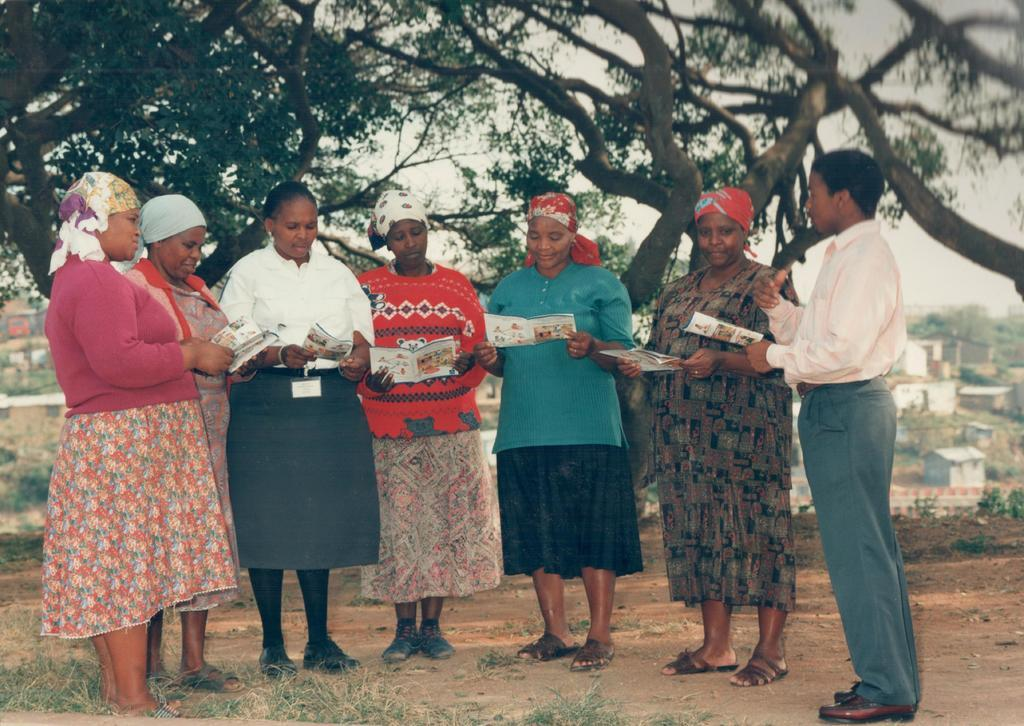What are the people in the image holding? The people in the image are holding papers. What position are the people in? The people are standing. What can be seen in the background of the image? There are houses and trees in the background of the image. How many thumbs can be seen on the people holding papers in the image? There is no way to determine the number of thumbs visible on the people holding papers in the image, as the image does not provide enough detail to count individual fingers. 